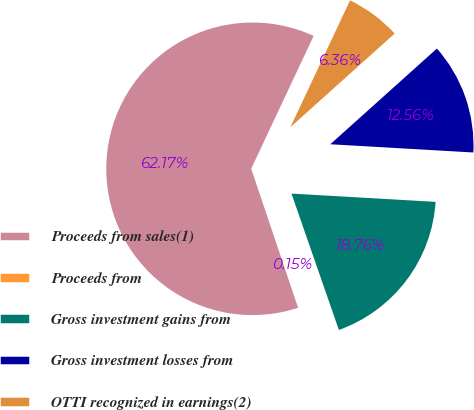<chart> <loc_0><loc_0><loc_500><loc_500><pie_chart><fcel>Proceeds from sales(1)<fcel>Proceeds from<fcel>Gross investment gains from<fcel>Gross investment losses from<fcel>OTTI recognized in earnings(2)<nl><fcel>62.18%<fcel>0.15%<fcel>18.76%<fcel>12.56%<fcel>6.36%<nl></chart> 